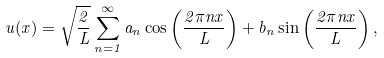<formula> <loc_0><loc_0><loc_500><loc_500>u ( x ) = \sqrt { \frac { 2 } { L } } \sum _ { n = 1 } ^ { \infty } a _ { n } \cos \left ( \frac { 2 \pi n x } { L } \right ) + b _ { n } \sin \left ( \frac { 2 \pi n x } { L } \right ) ,</formula> 